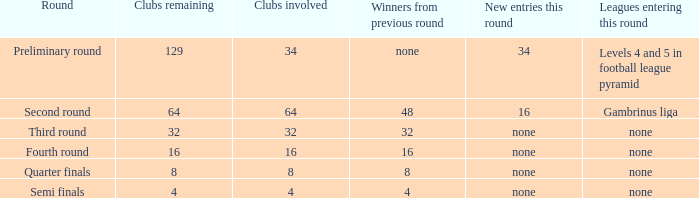Name the new entries this round for third round None. 